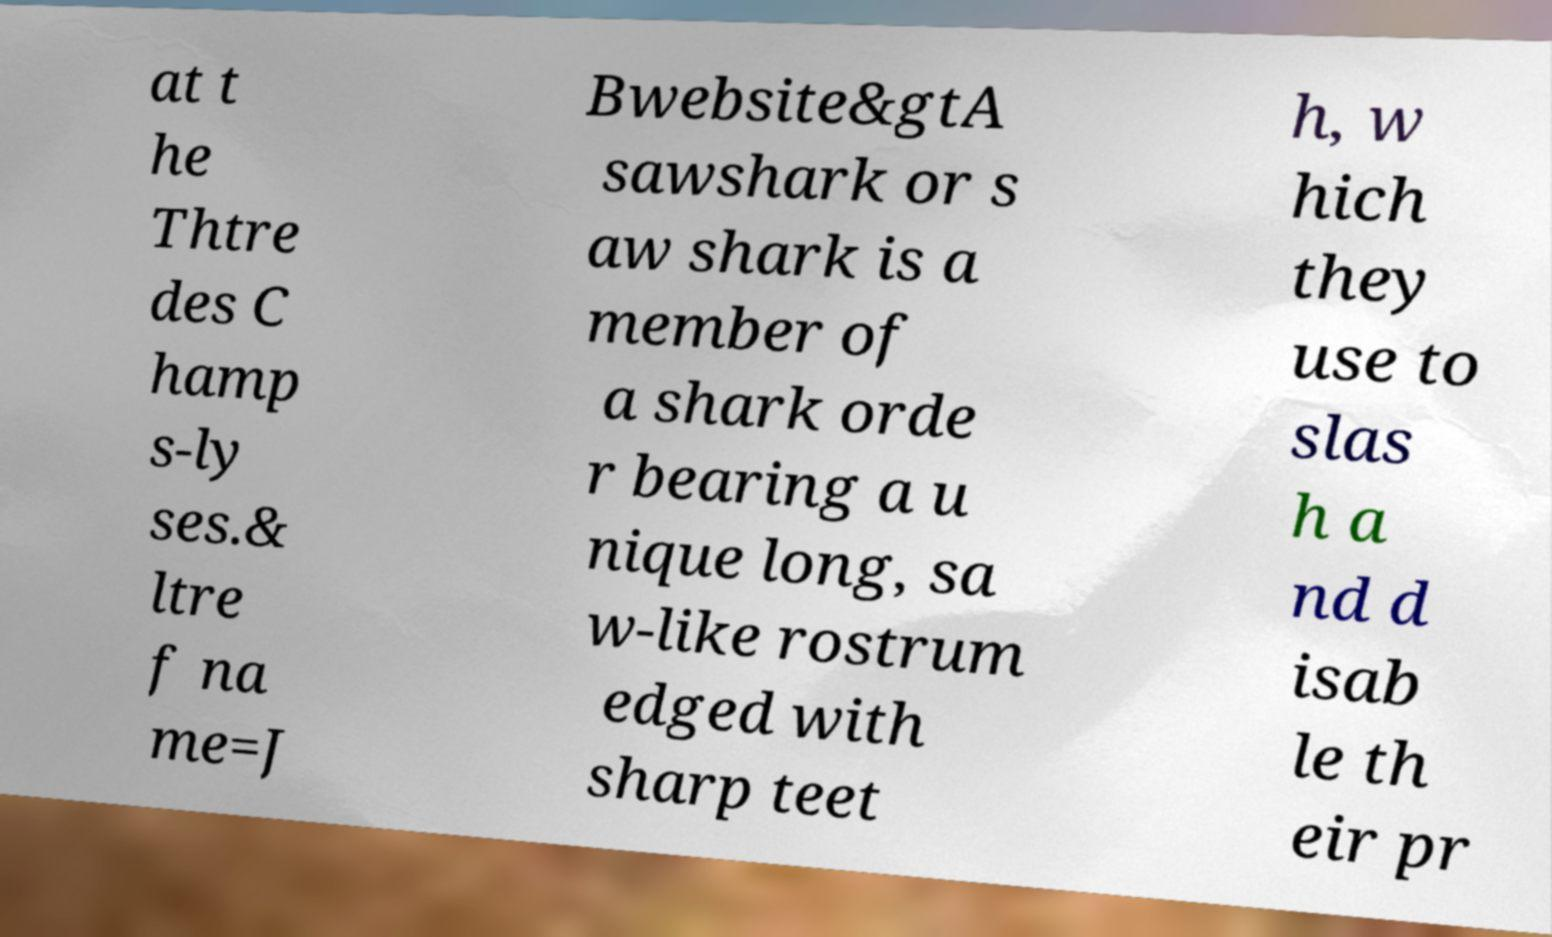Could you assist in decoding the text presented in this image and type it out clearly? at t he Thtre des C hamp s-ly ses.& ltre f na me=J Bwebsite&gtA sawshark or s aw shark is a member of a shark orde r bearing a u nique long, sa w-like rostrum edged with sharp teet h, w hich they use to slas h a nd d isab le th eir pr 